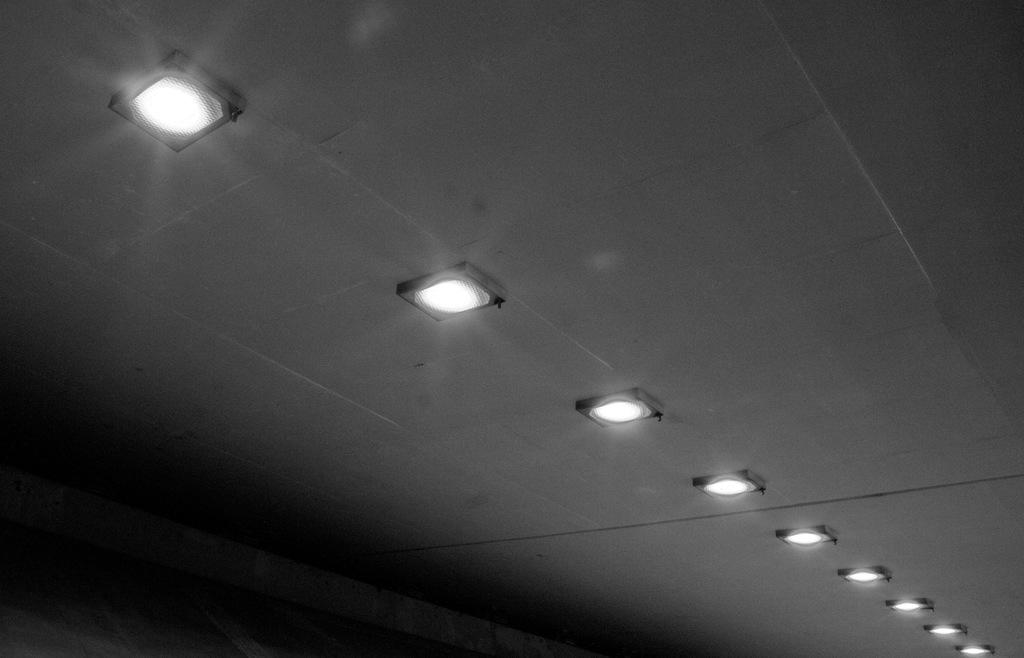What type of view is shown in the image? The image shows an inner view of a building. What part of the building can be seen in the image? There is a ceiling visible in the image. What is present on the ceiling in the image? There are lights on the ceiling. Can you tell me how many horses are visible in the image? There are no horses present in the image; it shows an inner view of a building with a ceiling and lights. 